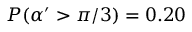<formula> <loc_0><loc_0><loc_500><loc_500>P ( \alpha ^ { \prime } > \pi / 3 ) = 0 . 2 0</formula> 